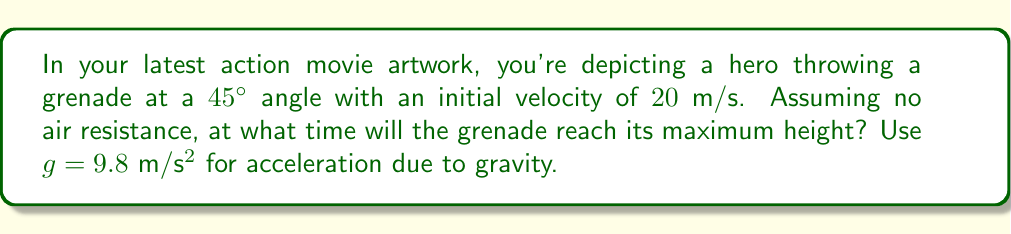Could you help me with this problem? To solve this problem, we'll use differential equations to analyze the trajectory of the thrown grenade.

Step 1: Set up the equations of motion.
We can describe the motion in two dimensions: horizontal (x) and vertical (y).

For the horizontal motion:
$$\frac{d^2x}{dt^2} = 0$$
$$\frac{dx}{dt} = v_0 \cos(\theta)$$
$$x(t) = (v_0 \cos(\theta))t$$

For the vertical motion:
$$\frac{d^2y}{dt^2} = -g$$
$$\frac{dy}{dt} = v_0 \sin(\theta) - gt$$
$$y(t) = (v_0 \sin(\theta))t - \frac{1}{2}gt^2$$

Step 2: Determine when the grenade reaches its maximum height.
The grenade will reach its maximum height when the vertical velocity is zero:

$$\frac{dy}{dt} = 0$$
$$v_0 \sin(\theta) - gt = 0$$

Step 3: Solve for time t.
$$t = \frac{v_0 \sin(\theta)}{g}$$

Step 4: Plug in the given values.
$v_0 = 20$ m/s
$\theta = 45^\circ$
$g = 9.8$ m/s²

$$t = \frac{20 \sin(45^\circ)}{9.8}$$
$$t = \frac{20 \cdot \frac{\sqrt{2}}{2}}{9.8}$$
$$t \approx 1.44 \text{ seconds}$$

Therefore, the grenade will reach its maximum height approximately 1.44 seconds after being thrown.
Answer: $1.44$ seconds 